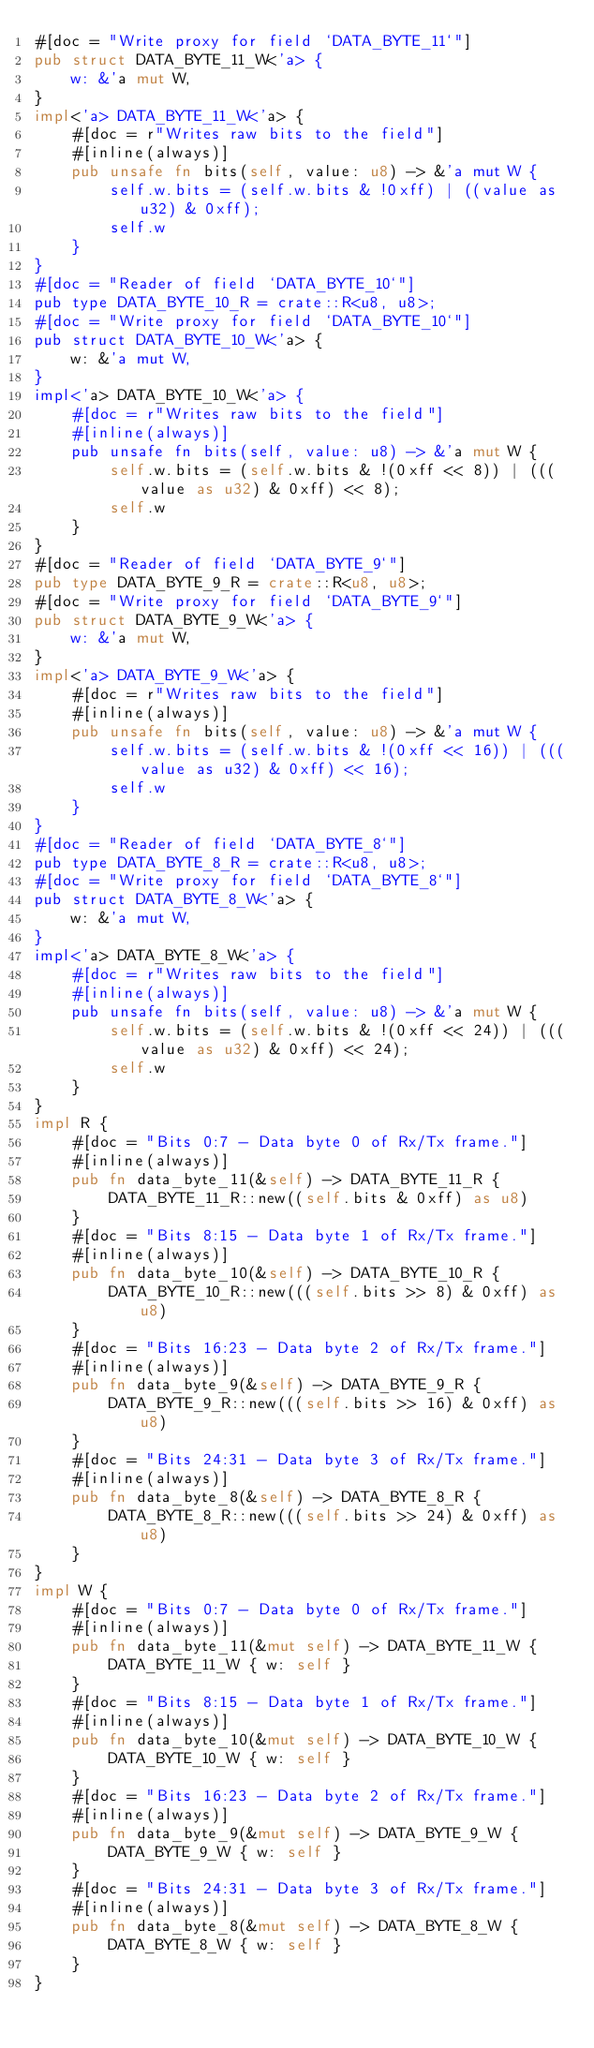<code> <loc_0><loc_0><loc_500><loc_500><_Rust_>#[doc = "Write proxy for field `DATA_BYTE_11`"]
pub struct DATA_BYTE_11_W<'a> {
    w: &'a mut W,
}
impl<'a> DATA_BYTE_11_W<'a> {
    #[doc = r"Writes raw bits to the field"]
    #[inline(always)]
    pub unsafe fn bits(self, value: u8) -> &'a mut W {
        self.w.bits = (self.w.bits & !0xff) | ((value as u32) & 0xff);
        self.w
    }
}
#[doc = "Reader of field `DATA_BYTE_10`"]
pub type DATA_BYTE_10_R = crate::R<u8, u8>;
#[doc = "Write proxy for field `DATA_BYTE_10`"]
pub struct DATA_BYTE_10_W<'a> {
    w: &'a mut W,
}
impl<'a> DATA_BYTE_10_W<'a> {
    #[doc = r"Writes raw bits to the field"]
    #[inline(always)]
    pub unsafe fn bits(self, value: u8) -> &'a mut W {
        self.w.bits = (self.w.bits & !(0xff << 8)) | (((value as u32) & 0xff) << 8);
        self.w
    }
}
#[doc = "Reader of field `DATA_BYTE_9`"]
pub type DATA_BYTE_9_R = crate::R<u8, u8>;
#[doc = "Write proxy for field `DATA_BYTE_9`"]
pub struct DATA_BYTE_9_W<'a> {
    w: &'a mut W,
}
impl<'a> DATA_BYTE_9_W<'a> {
    #[doc = r"Writes raw bits to the field"]
    #[inline(always)]
    pub unsafe fn bits(self, value: u8) -> &'a mut W {
        self.w.bits = (self.w.bits & !(0xff << 16)) | (((value as u32) & 0xff) << 16);
        self.w
    }
}
#[doc = "Reader of field `DATA_BYTE_8`"]
pub type DATA_BYTE_8_R = crate::R<u8, u8>;
#[doc = "Write proxy for field `DATA_BYTE_8`"]
pub struct DATA_BYTE_8_W<'a> {
    w: &'a mut W,
}
impl<'a> DATA_BYTE_8_W<'a> {
    #[doc = r"Writes raw bits to the field"]
    #[inline(always)]
    pub unsafe fn bits(self, value: u8) -> &'a mut W {
        self.w.bits = (self.w.bits & !(0xff << 24)) | (((value as u32) & 0xff) << 24);
        self.w
    }
}
impl R {
    #[doc = "Bits 0:7 - Data byte 0 of Rx/Tx frame."]
    #[inline(always)]
    pub fn data_byte_11(&self) -> DATA_BYTE_11_R {
        DATA_BYTE_11_R::new((self.bits & 0xff) as u8)
    }
    #[doc = "Bits 8:15 - Data byte 1 of Rx/Tx frame."]
    #[inline(always)]
    pub fn data_byte_10(&self) -> DATA_BYTE_10_R {
        DATA_BYTE_10_R::new(((self.bits >> 8) & 0xff) as u8)
    }
    #[doc = "Bits 16:23 - Data byte 2 of Rx/Tx frame."]
    #[inline(always)]
    pub fn data_byte_9(&self) -> DATA_BYTE_9_R {
        DATA_BYTE_9_R::new(((self.bits >> 16) & 0xff) as u8)
    }
    #[doc = "Bits 24:31 - Data byte 3 of Rx/Tx frame."]
    #[inline(always)]
    pub fn data_byte_8(&self) -> DATA_BYTE_8_R {
        DATA_BYTE_8_R::new(((self.bits >> 24) & 0xff) as u8)
    }
}
impl W {
    #[doc = "Bits 0:7 - Data byte 0 of Rx/Tx frame."]
    #[inline(always)]
    pub fn data_byte_11(&mut self) -> DATA_BYTE_11_W {
        DATA_BYTE_11_W { w: self }
    }
    #[doc = "Bits 8:15 - Data byte 1 of Rx/Tx frame."]
    #[inline(always)]
    pub fn data_byte_10(&mut self) -> DATA_BYTE_10_W {
        DATA_BYTE_10_W { w: self }
    }
    #[doc = "Bits 16:23 - Data byte 2 of Rx/Tx frame."]
    #[inline(always)]
    pub fn data_byte_9(&mut self) -> DATA_BYTE_9_W {
        DATA_BYTE_9_W { w: self }
    }
    #[doc = "Bits 24:31 - Data byte 3 of Rx/Tx frame."]
    #[inline(always)]
    pub fn data_byte_8(&mut self) -> DATA_BYTE_8_W {
        DATA_BYTE_8_W { w: self }
    }
}
</code> 